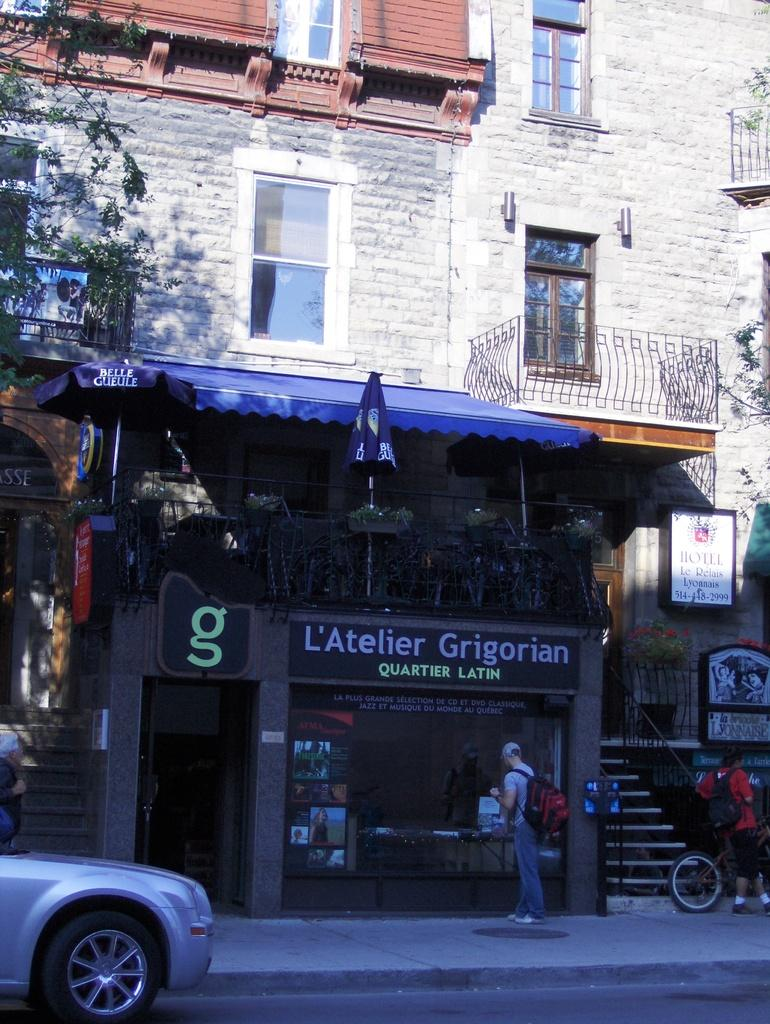What type of structure is in the image? There is a building in the image. What feature can be seen on the building? The building has windows. What type of establishment is located at the bottom of the building? There is a shop at the bottom of the building. What can be seen to the left of the building? There is a car to the left of the building. How does the maid contribute to the pollution in the image? There is no maid present in the image, and therefore no contribution to pollution can be observed. 